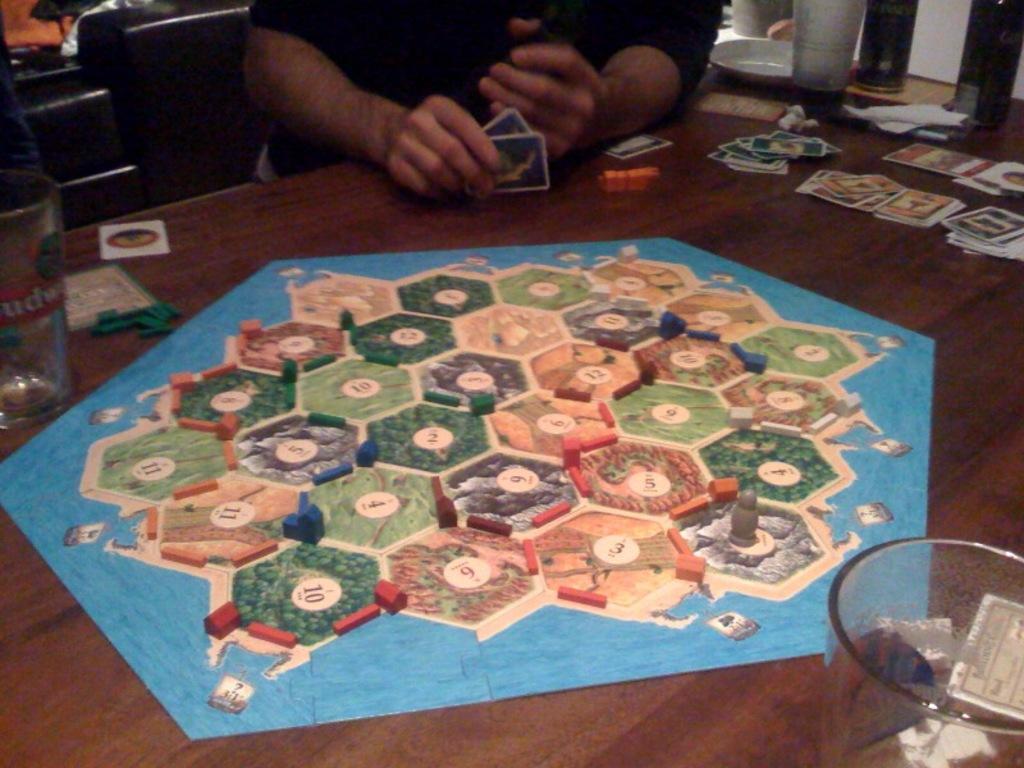Could you give a brief overview of what you see in this image? This image is clicked inside the room. In the front, there is a tale on which a game is placed. In the front, the man sitting is wearing black shirt and holding cards. To the left, there is a glass. To the right, there are tons and plate. 